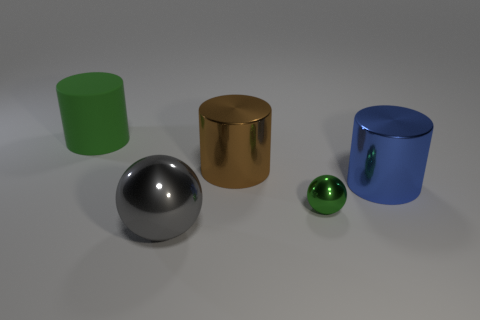What number of other things are there of the same color as the large rubber object?
Ensure brevity in your answer.  1. There is a green thing behind the big blue metallic cylinder; what is its shape?
Provide a short and direct response. Cylinder. Do the large green cylinder and the large blue cylinder have the same material?
Ensure brevity in your answer.  No. Are there any other things that have the same size as the rubber cylinder?
Provide a short and direct response. Yes. What number of tiny green shiny objects are in front of the large green matte cylinder?
Give a very brief answer. 1. What is the shape of the green thing behind the shiny sphere that is behind the large gray sphere?
Offer a terse response. Cylinder. Are there any other things that have the same shape as the large green matte thing?
Ensure brevity in your answer.  Yes. Is the number of large brown cylinders in front of the brown shiny thing greater than the number of green spheres?
Provide a succinct answer. No. What number of big gray spheres are behind the green thing that is to the left of the gray shiny thing?
Your answer should be very brief. 0. What shape is the green object that is left of the metallic thing that is in front of the metallic sphere behind the gray object?
Offer a very short reply. Cylinder. 